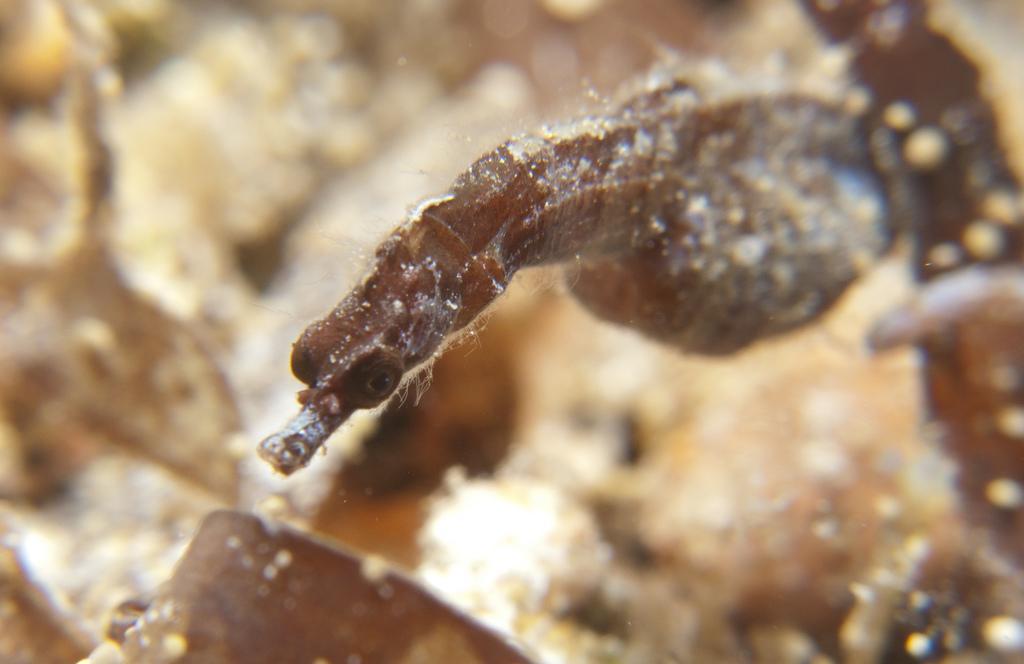In one or two sentences, can you explain what this image depicts? In this image there is a seahorse. The background is blurry. 